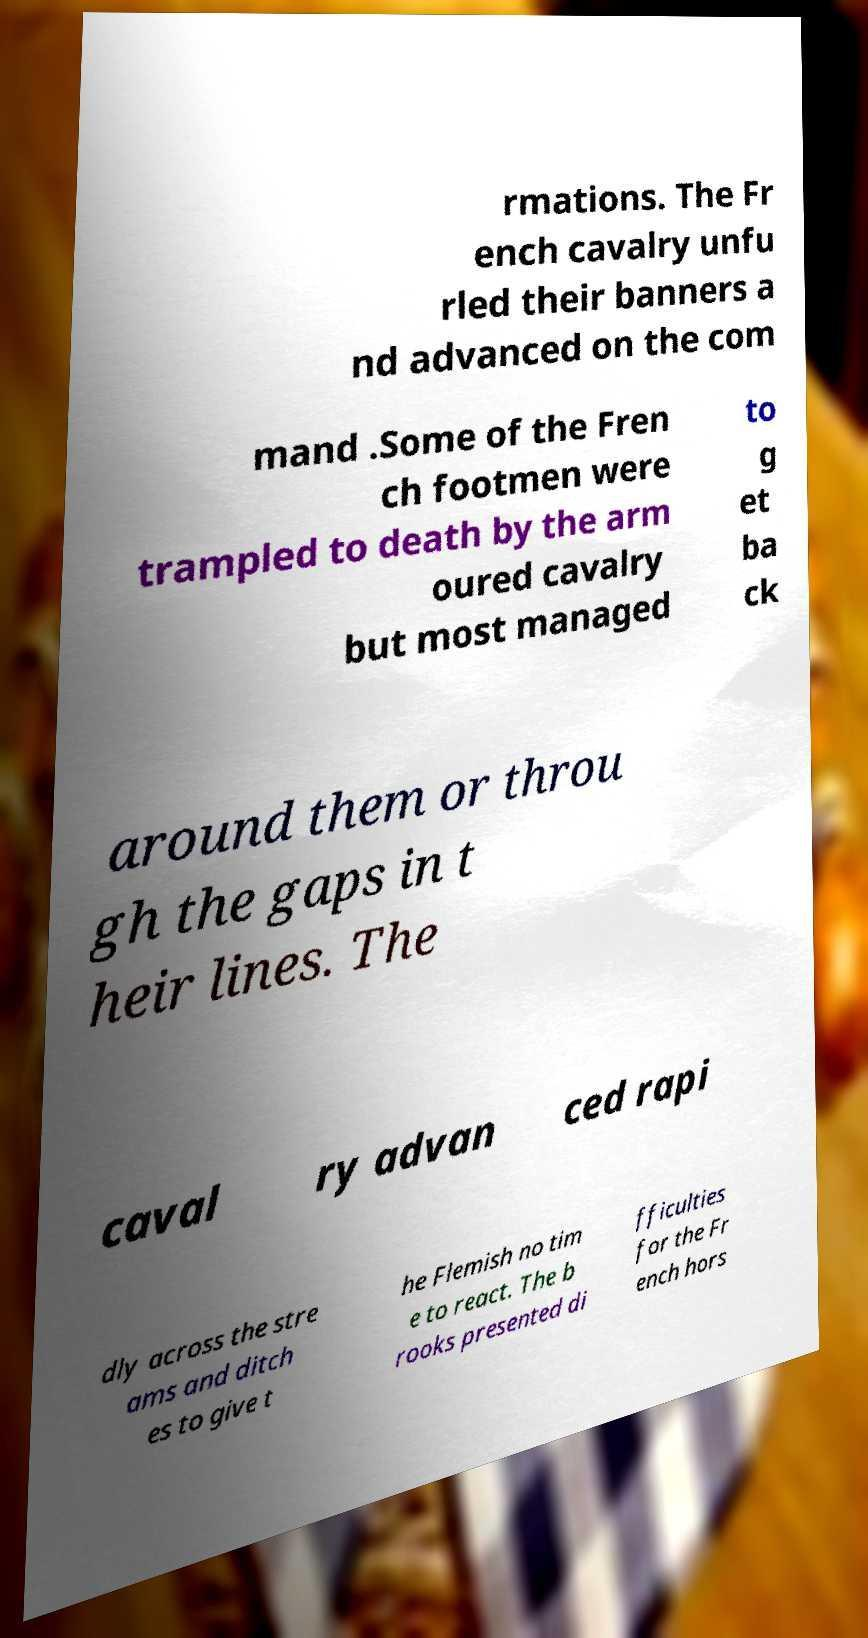Can you accurately transcribe the text from the provided image for me? rmations. The Fr ench cavalry unfu rled their banners a nd advanced on the com mand .Some of the Fren ch footmen were trampled to death by the arm oured cavalry but most managed to g et ba ck around them or throu gh the gaps in t heir lines. The caval ry advan ced rapi dly across the stre ams and ditch es to give t he Flemish no tim e to react. The b rooks presented di fficulties for the Fr ench hors 